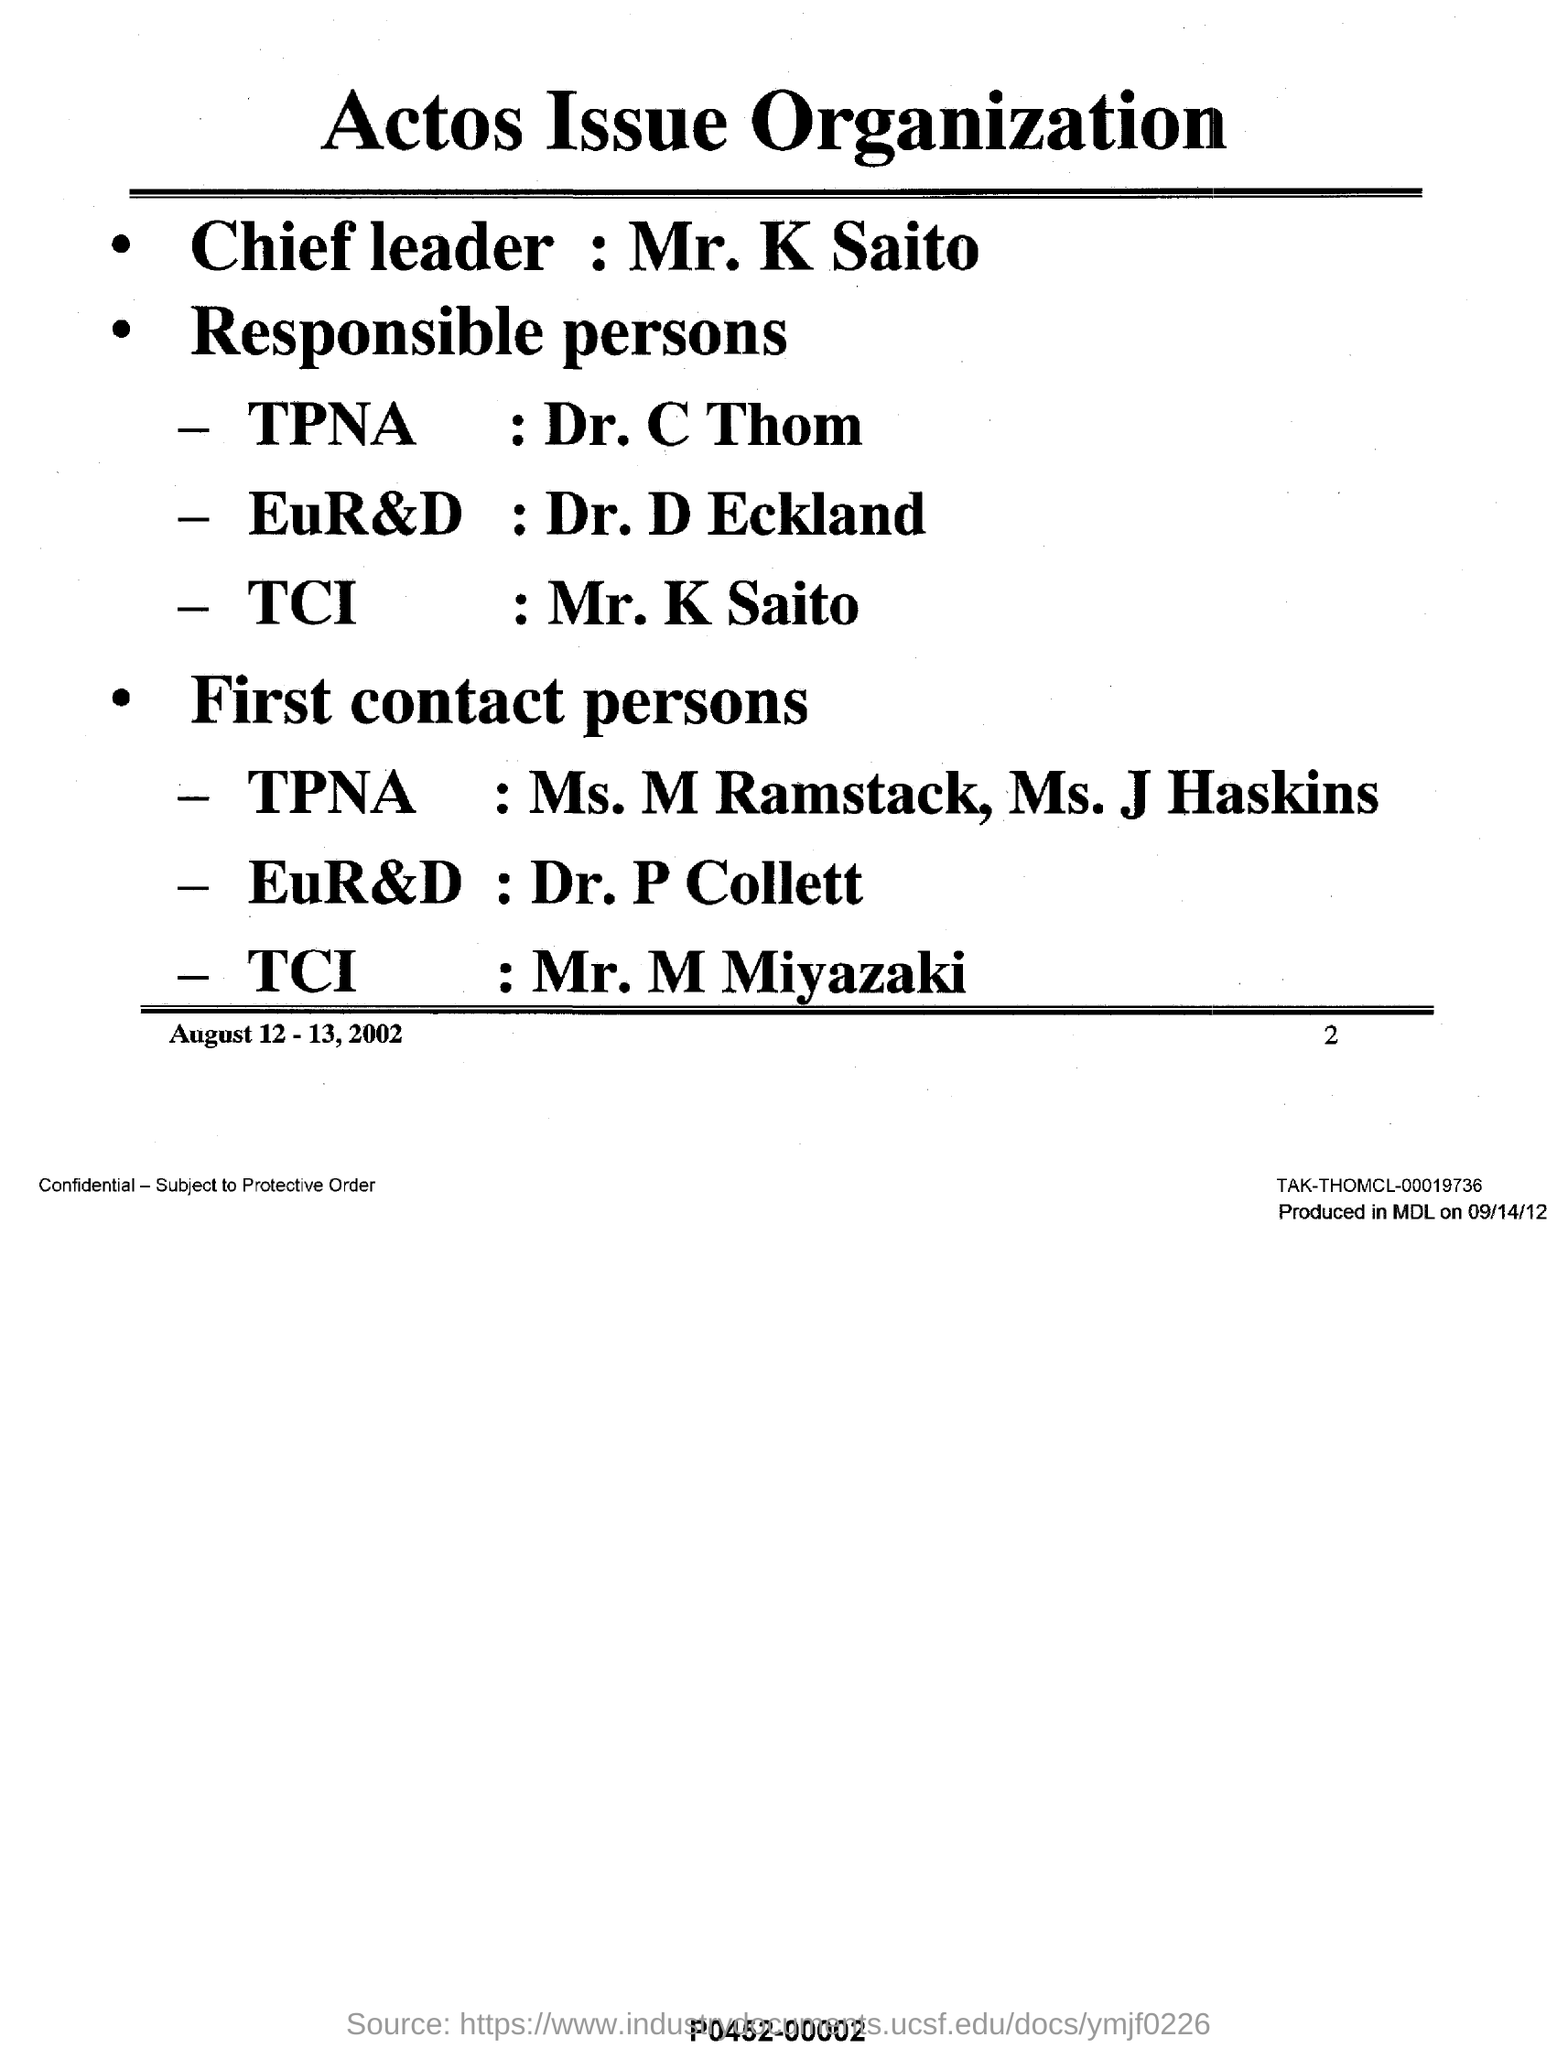Mention a couple of crucial points in this snapshot. It is Dr. D Eckland who is responsible for EuR&D. The name of the organization that deals with the Actos issue is Actos Issue Organization. The first contact person at TPNA is Ms. M Ramstack and Ms. J Haskins. TPNA is responsible for the actions of Dr. C Thom. Mr. K Saito is the responsible person of TCI. 